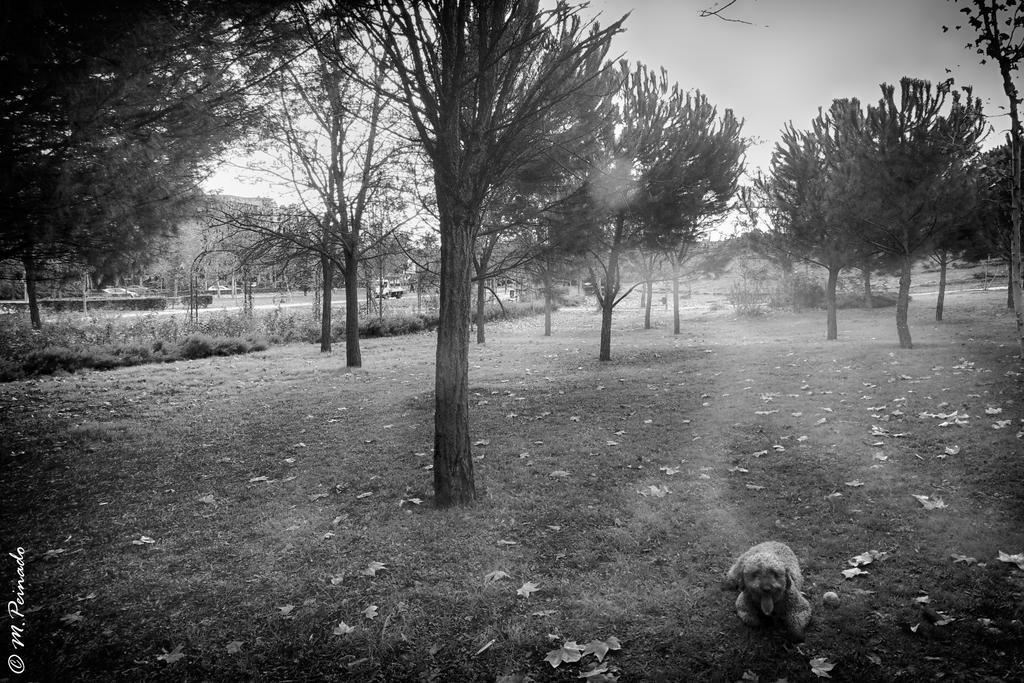Can you describe this image briefly? In the image we can see black and white picture of the dog, trees, grass and dry leaves. On the bottom left we can see the watermark and the sky. 